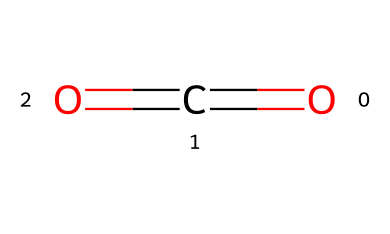What is the basic structure of carbon dioxide? The SMILES representation "O=C=O" indicates that carbon dioxide consists of one carbon atom (C) double bonded to two oxygen atoms (O). This is a linear molecule.
Answer: linear How many atoms are present in carbon dioxide? The SMILES notation shows one carbon atom and two oxygen atoms. Therefore, there are a total of three atoms in carbon dioxide.
Answer: three What type of bonding exists between the carbon and oxygen atoms in CO2? In the SMILES representation "O=C=O", the equal sign "=" denotes double bonds between the carbon atom and each of the oxygen atoms, indicating that CO2 exhibits double bonding.
Answer: double bond Is carbon dioxide a refrigerant? Carbon dioxide is classified as a refrigerant, particularly useful in heat pumps and some automotive air conditioning systems due to its thermodynamic properties.
Answer: yes Why is carbon dioxide considered an environmentally friendly refrigerant? CO2 has a low global warming potential compared to traditional refrigerants, making it a more sustainable and environmentally friendly choice in cooling applications.
Answer: low global warming potential What phase of carbon dioxide is commonly used in refrigeration systems? Carbon dioxide is typically utilized in its supercritical phase for efficient heat transfer and energy efficiency in refrigeration applications.
Answer: supercritical How many double bonds are in carbon dioxide? The SMILES notation "O=C=O" indicates two double bonds between one carbon atom and two oxygen atoms.
Answer: two 